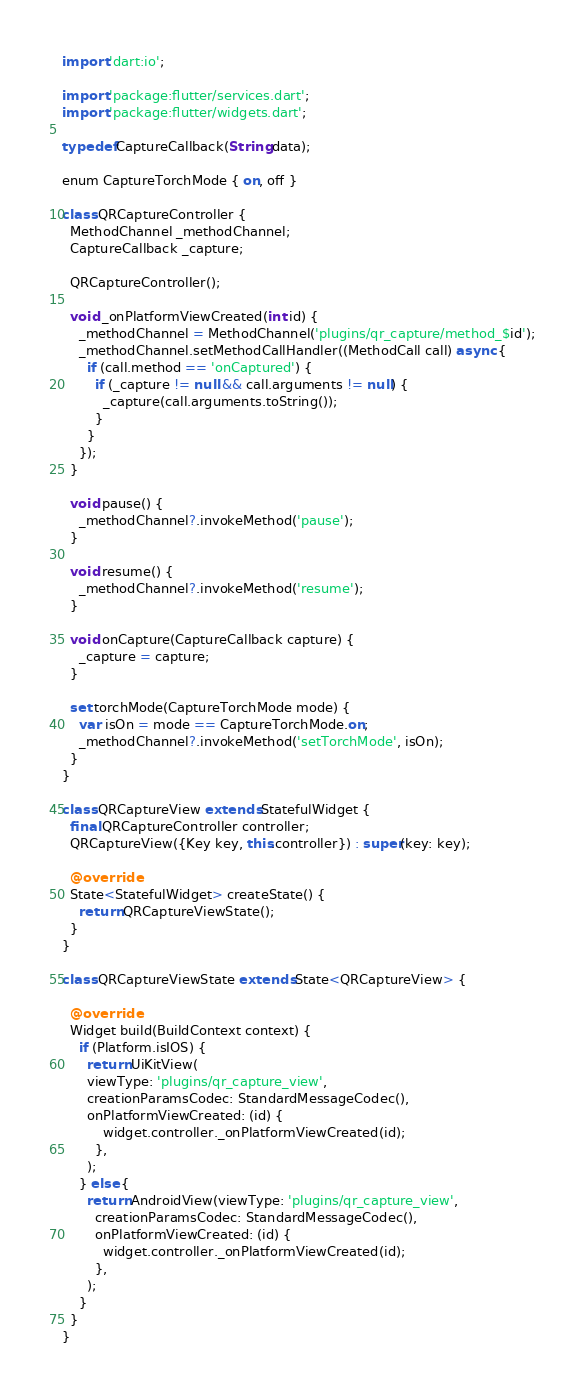<code> <loc_0><loc_0><loc_500><loc_500><_Dart_>import 'dart:io';

import 'package:flutter/services.dart';
import 'package:flutter/widgets.dart';

typedef CaptureCallback(String data);

enum CaptureTorchMode { on, off }

class QRCaptureController {
  MethodChannel _methodChannel; 
  CaptureCallback _capture; 
  
  QRCaptureController();

  void _onPlatformViewCreated(int id) {
    _methodChannel = MethodChannel('plugins/qr_capture/method_$id');
    _methodChannel.setMethodCallHandler((MethodCall call) async {
      if (call.method == 'onCaptured') { 
        if (_capture != null && call.arguments != null) {
          _capture(call.arguments.toString());
        }
      }
    });
  }

  void pause() {
    _methodChannel?.invokeMethod('pause');
  }

  void resume() {
    _methodChannel?.invokeMethod('resume');
  }

  void onCapture(CaptureCallback capture) {
    _capture = capture;
  }

  set torchMode(CaptureTorchMode mode) {
    var isOn = mode == CaptureTorchMode.on;
    _methodChannel?.invokeMethod('setTorchMode', isOn);
  }
}

class QRCaptureView extends StatefulWidget {
  final QRCaptureController controller;
  QRCaptureView({Key key, this.controller}) : super(key: key);

  @override
  State<StatefulWidget> createState() {
    return QRCaptureViewState();
  }
}

class QRCaptureViewState extends State<QRCaptureView> {

  @override
  Widget build(BuildContext context) {
    if (Platform.isIOS) {
      return UiKitView(
      viewType: 'plugins/qr_capture_view',
      creationParamsCodec: StandardMessageCodec(),
      onPlatformViewCreated: (id) {
          widget.controller._onPlatformViewCreated(id);
        },
      );
    } else {
      return AndroidView(viewType: 'plugins/qr_capture_view',
        creationParamsCodec: StandardMessageCodec(),
        onPlatformViewCreated: (id) {
          widget.controller._onPlatformViewCreated(id);
        },
      );
    }
  }
}</code> 